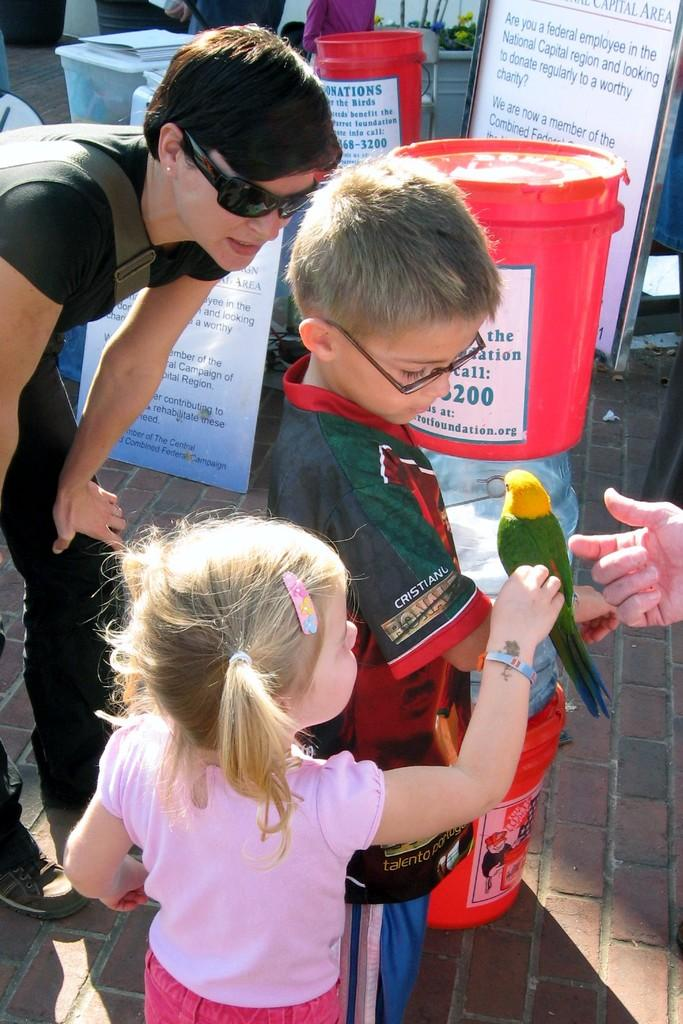Who or what is present in the image? There are people in the image. What is the bird doing in the image? A bird is standing on a boy's hand. What can be seen on the boards in the image? There are boards with text in the image. What is on the floor in the image? There are objects with posters on the floor. What type of rings can be seen on the lunchroom table in the image? There is no lunchroom table or rings present in the image. How many people are laughing in the image? The image does not depict anyone laughing, so it cannot be determined how many people are laughing. 